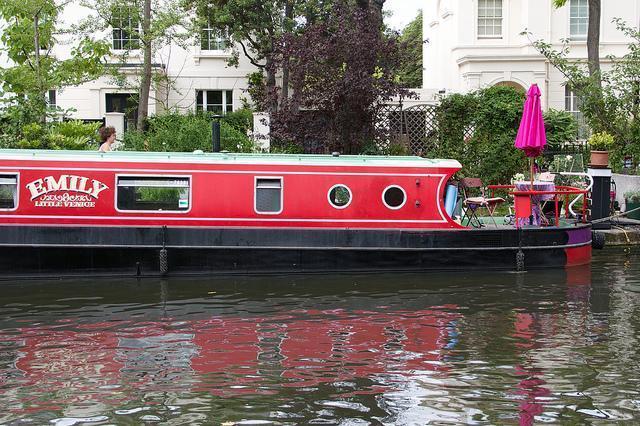How many windows can you see on the boat?
Give a very brief answer. 5. 